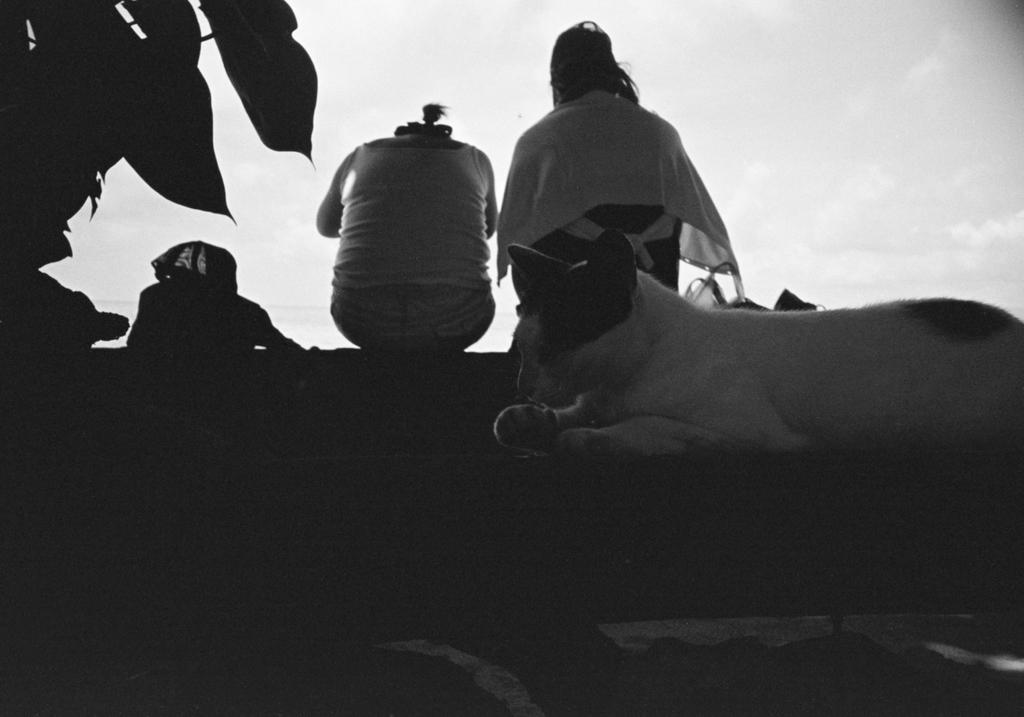How many people are present in the image? There are two people sitting in the image. What other living creature can be seen in the image? There is a cat in the image. What can be seen in the background of the image? The sky is visible in the background of the image. What type of food is the fireman feeding to the animals at the zoo in the image? There is no fireman, food, or zoo present in the image. The image features two people sitting and a cat, with the sky visible in the background. 